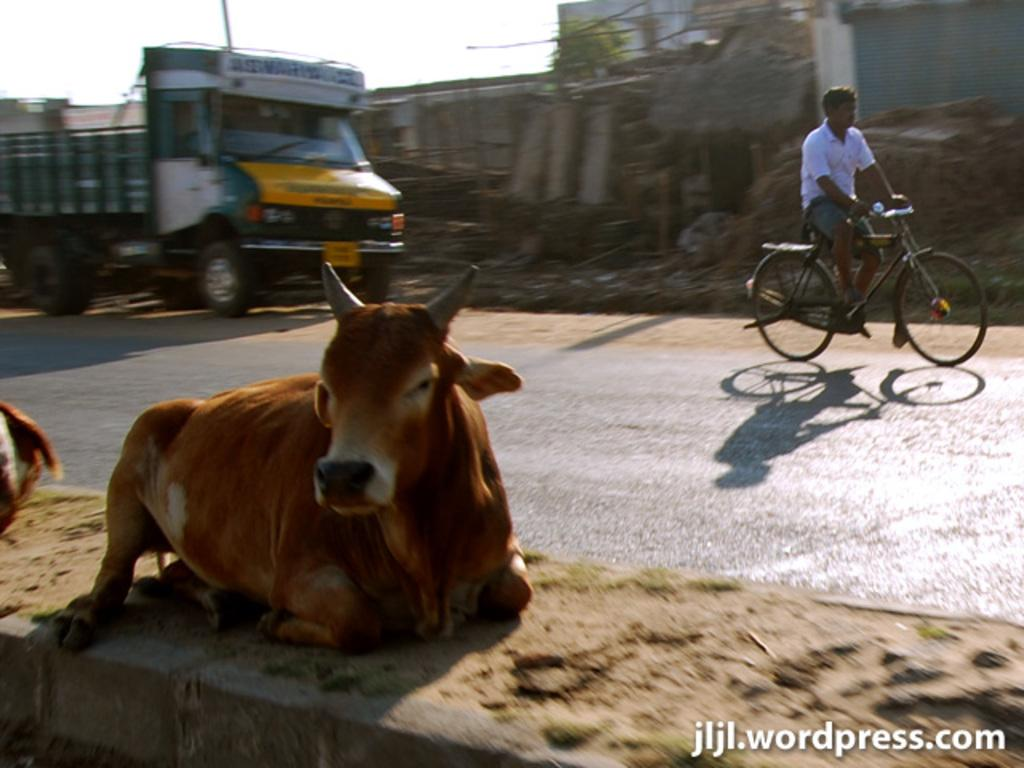What is the person in the image doing? There is a person riding a bicycle on the road in the image. What vehicle is behind the bicycle? There is a lorry behind the bicycle in the image. What type of animal can be seen in the image? There is a cow in the image. What structure is beside the road? There is a building beside the road in the image. What part of the sky is visible in the image? The sky is visible at the top left of the image. What type of gate is present in the image? There is no gate present in the image. What material is the iron used for in the image? There is no iron or any iron-related objects present in the image. 